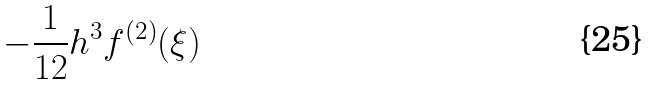Convert formula to latex. <formula><loc_0><loc_0><loc_500><loc_500>- { \frac { 1 } { 1 2 } } h ^ { 3 } f ^ { ( 2 ) } ( \xi )</formula> 